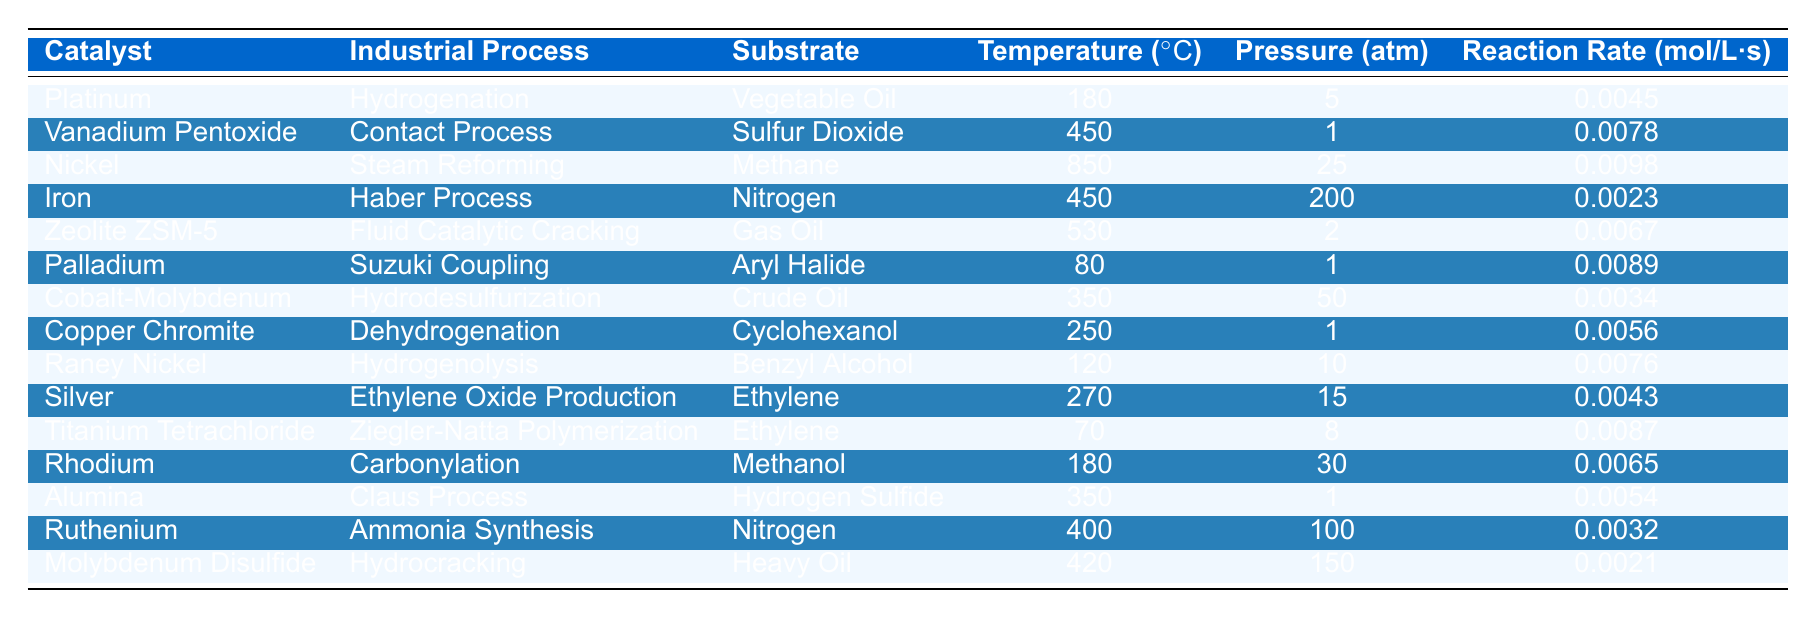What catalyst is used in the Hydrogenation process? The table contains a row for the Hydrogenation process, where the catalyst listed is Platinum.
Answer: Platinum Which substrate is being processed at a temperature of 450°C? Looking at the rows with a temperature of 450°C, there are two substrates: Sulfur Dioxide (with Vanadium Pentoxide as catalyst) and Nitrogen (with Iron as catalyst).
Answer: Sulfur Dioxide and Nitrogen What is the reaction rate for Nickel in Steam Reforming? According to the table, Nickel in the Steam Reforming process shows a reaction rate of 0.0098 mol/L·s.
Answer: 0.0098 mol/L·s Is the reaction rate for Cobalt-Molybdenum higher than that for Raney Nickel? The reaction rate for Cobalt-Molybdenum is 0.0034 mol/L·s, while for Raney Nickel it is 0.0076 mol/L·s, showing that Raney Nickel has a higher reaction rate.
Answer: No What is the average reaction rate of catalysts that operate at 350°C? The catalysts operating at 350°C are Cobalt-Molybdenum (0.0034 mol/L·s), Alumina (0.0054 mol/L·s), and another one is the Hydrodesulfurization (0.0054 mol/L·s). We sum these rates (0.0034 + 0.0054 = 0.0088) and divide by 2 (0.0088/2 = 0.0044 mol/L·s) for the two distinct catalysts.
Answer: 0.0044 mol/L·s Identify the catalyst with the lowest reaction rate. Scanning the reaction rates listed, Molybdenum Disulfide in Hydrocracking has the lowest rate at 0.0021 mol/L·s.
Answer: Molybdenum Disulfide If we were to increase the temperature to 850°C, would we expect to see a higher reaction rate than that of Platinum's Hydrogenation rate? The reaction rate for Nickel at 850°C is 0.0098 mol/L·s, which is significantly higher than Platinum's reaction rate of 0.0045 mol/L·s in Hydrogenation. Thus, we would expect a higher reaction rate.
Answer: Yes How does the pressure affect the reaction rate of the catalysts showcased? Examining the table, we see a range of pressures but there's no consistent trend indicating pressure's direct impact on reaction rates across the catalysts—it varies differently for each catalyst. Further analysis would be needed for concrete conclusions.
Answer: Not consistent What is the difference in reaction rate between Vanadium Pentoxide and Palladium? The reaction rate for Vanadium Pentoxide is 0.0078 mol/L·s, while for Palladium it is 0.0089 mol/L·s. The difference is 0.0089 - 0.0078 = 0.0011 mol/L·s.
Answer: 0.0011 mol/L·s Which catalyst shows a reaction rate for two different processes? The table indicates that Iron serves in the Haber Process and has a reaction rate associated with it, but not for two processes; thus none of the listed catalysts shows a rate for two processes based on the data.
Answer: None What catalyst has the highest reaction rate and what is that rate? Nickle in Steam Reforming has the highest reaction rate of 0.0098 mol/L·s.
Answer: Nickel, 0.0098 mol/L·s 